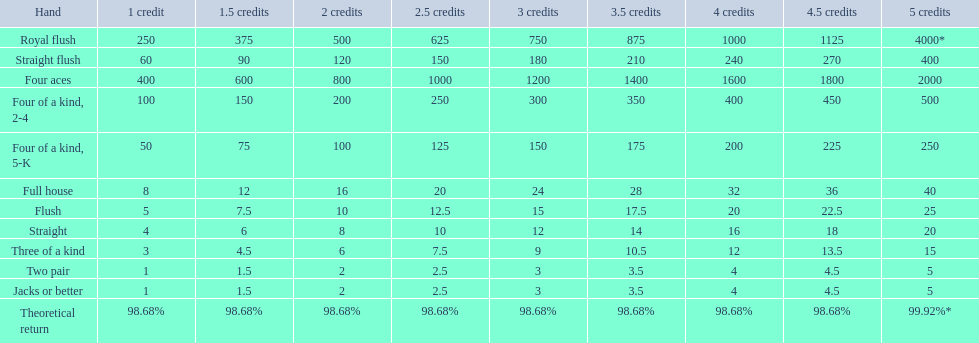What are the top 5 best types of hand for winning? Royal flush, Straight flush, Four aces, Four of a kind, 2-4, Four of a kind, 5-K. Between those 5, which of those hands are four of a kind? Four of a kind, 2-4, Four of a kind, 5-K. Of those 2 hands, which is the best kind of four of a kind for winning? Four of a kind, 2-4. 